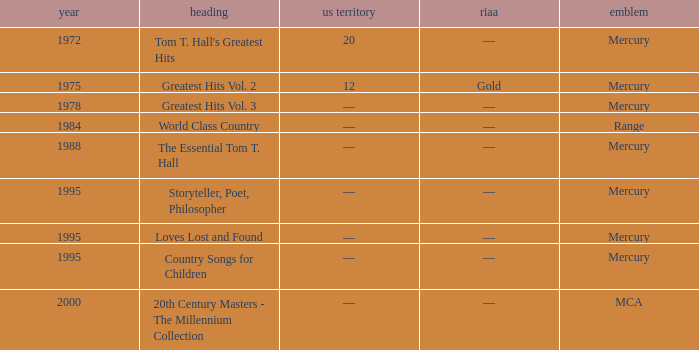What label had the album after 1978? Range, Mercury, Mercury, Mercury, Mercury, MCA. 